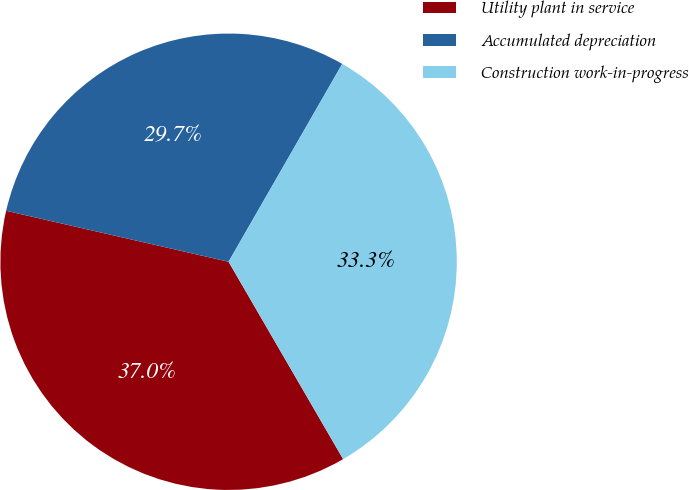<chart> <loc_0><loc_0><loc_500><loc_500><pie_chart><fcel>Utility plant in service<fcel>Accumulated depreciation<fcel>Construction work-in-progress<nl><fcel>36.95%<fcel>29.71%<fcel>33.33%<nl></chart> 